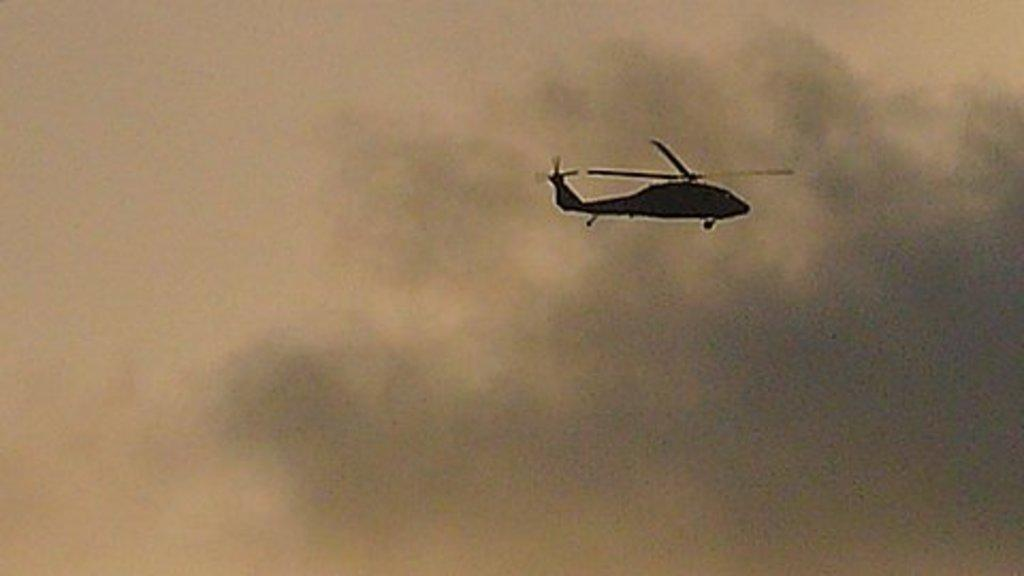What is the main subject in the sky in the image? There is a helicopter in the sky in the image. What is visible at the top of the image? The sky is visible at the top of the image. What can be seen in the sky besides the helicopter? There are clouds in the sky. Where is the waste container located in the image? There is no waste container present in the image. What type of wheel can be seen attached to the helicopter in the image? There are no wheels visible on the helicopter in the image, as helicopters typically do not have wheels. 